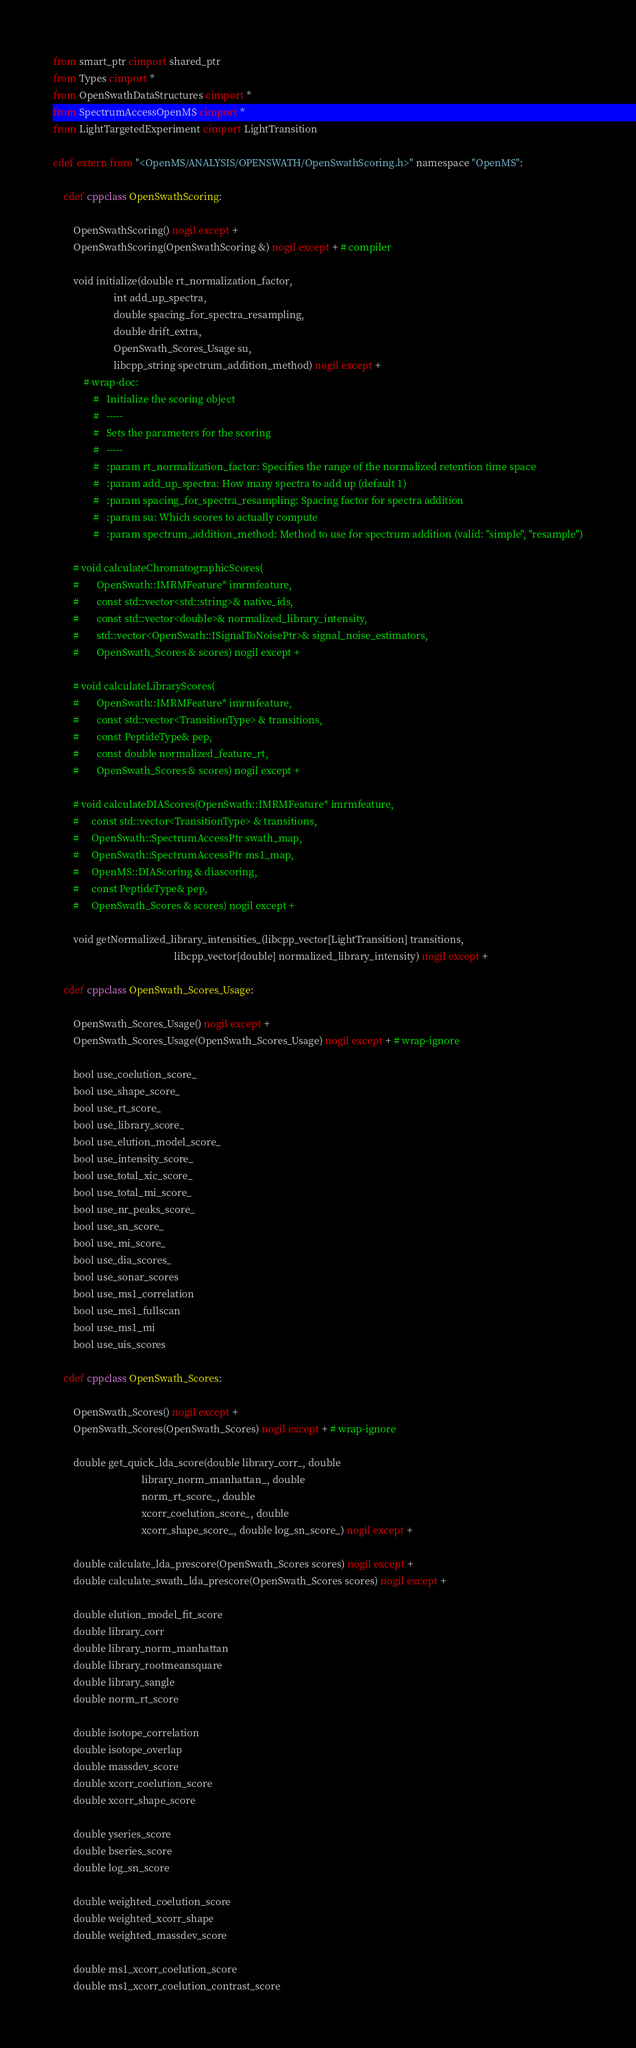<code> <loc_0><loc_0><loc_500><loc_500><_Cython_>from smart_ptr cimport shared_ptr
from Types cimport *
from OpenSwathDataStructures cimport *
from SpectrumAccessOpenMS cimport *
from LightTargetedExperiment cimport LightTransition

cdef extern from "<OpenMS/ANALYSIS/OPENSWATH/OpenSwathScoring.h>" namespace "OpenMS":

    cdef cppclass OpenSwathScoring:

        OpenSwathScoring() nogil except +
        OpenSwathScoring(OpenSwathScoring &) nogil except + # compiler

        void initialize(double rt_normalization_factor,
                        int add_up_spectra,
                        double spacing_for_spectra_resampling,
                        double drift_extra,
                        OpenSwath_Scores_Usage su,
                        libcpp_string spectrum_addition_method) nogil except +
            # wrap-doc:
                #   Initialize the scoring object
                #   -----
                #   Sets the parameters for the scoring
                #   -----
                #   :param rt_normalization_factor: Specifies the range of the normalized retention time space
                #   :param add_up_spectra: How many spectra to add up (default 1)
                #   :param spacing_for_spectra_resampling: Spacing factor for spectra addition
                #   :param su: Which scores to actually compute
                #   :param spectrum_addition_method: Method to use for spectrum addition (valid: "simple", "resample")

        # void calculateChromatographicScores(
        #       OpenSwath::IMRMFeature* imrmfeature,
        #       const std::vector<std::string>& native_ids,
        #       const std::vector<double>& normalized_library_intensity,
        #       std::vector<OpenSwath::ISignalToNoisePtr>& signal_noise_estimators,
        #       OpenSwath_Scores & scores) nogil except +

        # void calculateLibraryScores(
        #       OpenSwath::IMRMFeature* imrmfeature,
        #       const std::vector<TransitionType> & transitions,
        #       const PeptideType& pep,
        #       const double normalized_feature_rt,
        #       OpenSwath_Scores & scores) nogil except +

        # void calculateDIAScores(OpenSwath::IMRMFeature* imrmfeature, 
        #     const std::vector<TransitionType> & transitions,
        #     OpenSwath::SpectrumAccessPtr swath_map,
        #     OpenSwath::SpectrumAccessPtr ms1_map,
        #     OpenMS::DIAScoring & diascoring,
        #     const PeptideType& pep,
        #     OpenSwath_Scores & scores) nogil except +

        void getNormalized_library_intensities_(libcpp_vector[LightTransition] transitions,
                                                libcpp_vector[double] normalized_library_intensity) nogil except +

    cdef cppclass OpenSwath_Scores_Usage:

        OpenSwath_Scores_Usage() nogil except +
        OpenSwath_Scores_Usage(OpenSwath_Scores_Usage) nogil except + # wrap-ignore

        bool use_coelution_score_
        bool use_shape_score_
        bool use_rt_score_
        bool use_library_score_
        bool use_elution_model_score_
        bool use_intensity_score_
        bool use_total_xic_score_
        bool use_total_mi_score_
        bool use_nr_peaks_score_
        bool use_sn_score_
        bool use_mi_score_
        bool use_dia_scores_
        bool use_sonar_scores
        bool use_ms1_correlation
        bool use_ms1_fullscan
        bool use_ms1_mi
        bool use_uis_scores

    cdef cppclass OpenSwath_Scores:

        OpenSwath_Scores() nogil except +
        OpenSwath_Scores(OpenSwath_Scores) nogil except + # wrap-ignore

        double get_quick_lda_score(double library_corr_, double
                                   library_norm_manhattan_, double
                                   norm_rt_score_, double
                                   xcorr_coelution_score_, double
                                   xcorr_shape_score_, double log_sn_score_) nogil except +

        double calculate_lda_prescore(OpenSwath_Scores scores) nogil except +
        double calculate_swath_lda_prescore(OpenSwath_Scores scores) nogil except +

        double elution_model_fit_score
        double library_corr
        double library_norm_manhattan
        double library_rootmeansquare
        double library_sangle
        double norm_rt_score

        double isotope_correlation
        double isotope_overlap
        double massdev_score
        double xcorr_coelution_score
        double xcorr_shape_score

        double yseries_score
        double bseries_score
        double log_sn_score

        double weighted_coelution_score
        double weighted_xcorr_shape
        double weighted_massdev_score
       
        double ms1_xcorr_coelution_score
        double ms1_xcorr_coelution_contrast_score</code> 